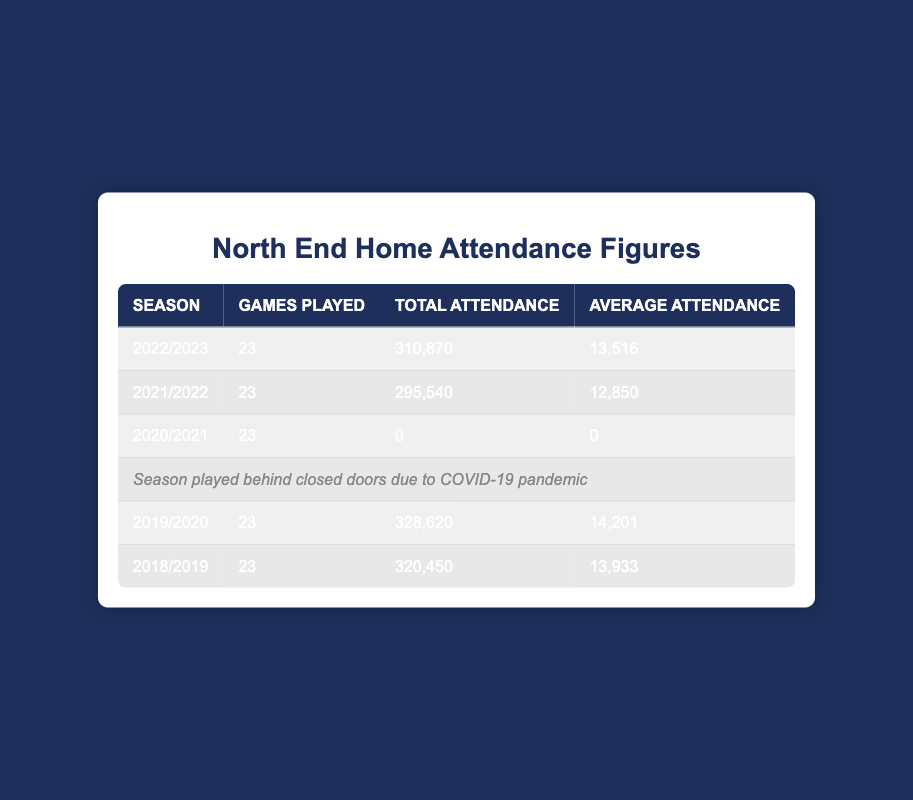What was the average attendance in the 2019/2020 season? The average attendance for the 2019/2020 season is listed directly in the table. It shows an average attendance of 14201 for that season.
Answer: 14201 How many games were played in the 2021/2022 season? The number of games played for the 2021/2022 season is provided in the table, indicating it was 23 games.
Answer: 23 What was the total attendance in the 2020/2021 season? According to the table, the total attendance for the 2020/2021 season is recorded as 0. This aligns with the note that states this season was played behind closed doors due to COVID-19.
Answer: 0 What was the difference in average attendance between the 2018/2019 and 2022/2023 seasons? The average attendance for 2018/2019 was 13933, and for 2022/2023 it was 13516. Calculating the difference gives 13933 - 13516 = 417.
Answer: 417 Did the total attendance for the 2019/2020 season exceed that of the 2021/2022 season? Looking at the respective total attendance values of 328620 for 2019/2020 and 295540 for 2021/2022, it is clear that 328620 is greater than 295540. Thus, the answer is yes.
Answer: Yes What season had the highest average attendance? To determine which season had the highest average attendance, we can compare the averages: 13933 (2018/2019), 14201 (2019/2020), 12850 (2021/2022), and 13516 (2022/2023). The highest is 14201.
Answer: 2019/2020 Calculate the total attendance for seasons before 2021/2022. The total attendance for 2018/2019 is 320450, for 2019/2020 is 328620, and for 2020/2021 is 0. Adding them up gives us 320450 + 328620 + 0 = 649070.
Answer: 649070 Was there any season where the average attendance was below 13000? The average attendances for the seasons are: 13933 (2018/2019), 14201 (2019/2020), 0 (2020/2021), 12850 (2021/2022), and 13516 (2022/2023). The 2021/2022 season shows an average of 12850, which is below 13000. So yes, there was a season with average attendance below this threshold.
Answer: Yes What is the average attendance across the 2018/2019, 2019/2020, and 2022/2023 seasons? The average attendances for those seasons are 13933 (2018/2019), 14201 (2019/2020), and 13516 (2022/2023). Summing these gives us 13933 + 14201 + 13516 = 41650, and dividing by 3 results in an average of 13883.33.
Answer: 13883.33 